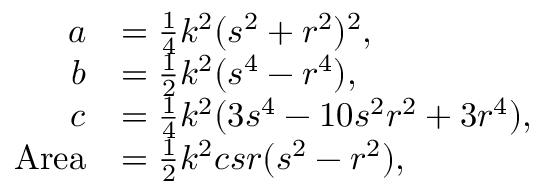<formula> <loc_0><loc_0><loc_500><loc_500>{ \begin{array} { r l } { a } & { = { \frac { 1 } { 4 } } k ^ { 2 } ( s ^ { 2 } + r ^ { 2 } ) ^ { 2 } , } \\ { b } & { = { \frac { 1 } { 2 } } k ^ { 2 } ( s ^ { 4 } - r ^ { 4 } ) , } \\ { c } & { = { \frac { 1 } { 4 } } k ^ { 2 } ( 3 s ^ { 4 } - 1 0 s ^ { 2 } r ^ { 2 } + 3 r ^ { 4 } ) , } \\ { A r e a } & { = { \frac { 1 } { 2 } } k ^ { 2 } c s r ( s ^ { 2 } - r ^ { 2 } ) , } \end{array} }</formula> 